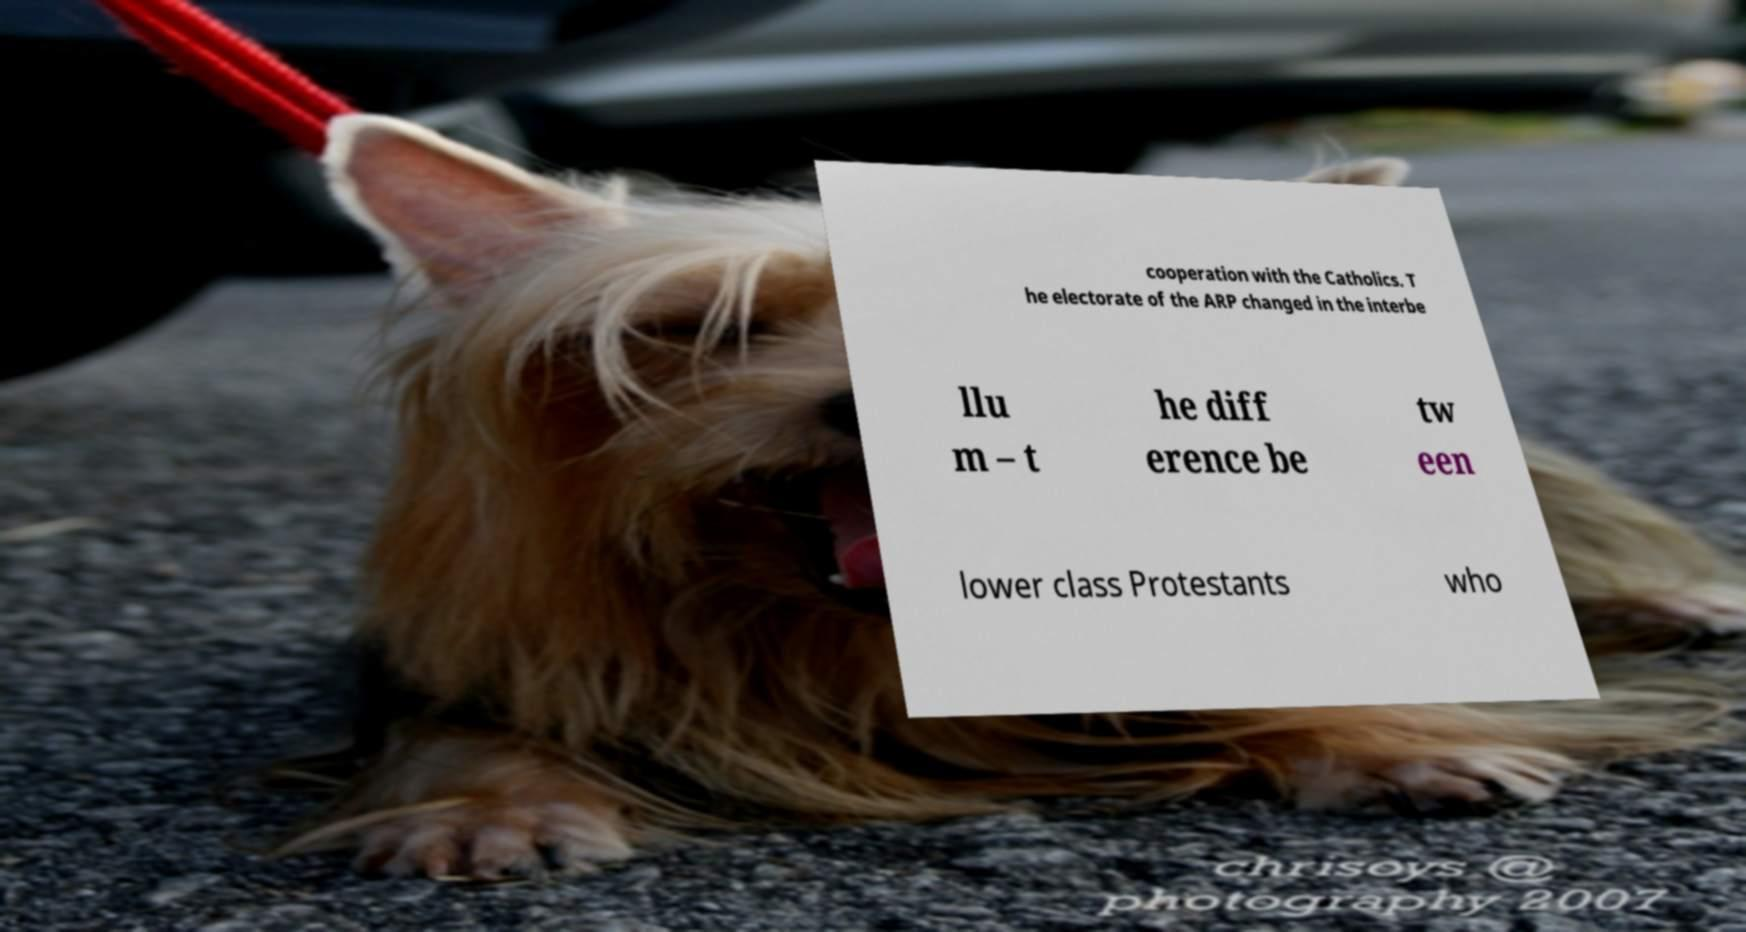Can you accurately transcribe the text from the provided image for me? cooperation with the Catholics. T he electorate of the ARP changed in the interbe llu m – t he diff erence be tw een lower class Protestants who 